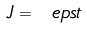<formula> <loc_0><loc_0><loc_500><loc_500>J = \ e p s t</formula> 